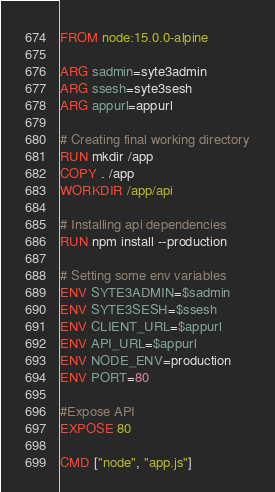<code> <loc_0><loc_0><loc_500><loc_500><_Dockerfile_>FROM node:15.0.0-alpine

ARG sadmin=syte3admin
ARG ssesh=syte3sesh
ARG appurl=appurl

# Creating final working directory
RUN mkdir /app
COPY . /app
WORKDIR /app/api

# Installing api dependencies
RUN npm install --production

# Setting some env variables
ENV SYTE3ADMIN=$sadmin
ENV SYTE3SESH=$ssesh
ENV CLIENT_URL=$appurl
ENV API_URL=$appurl
ENV NODE_ENV=production
ENV PORT=80

#Expose API
EXPOSE 80

CMD ["node", "app.js"]


</code> 